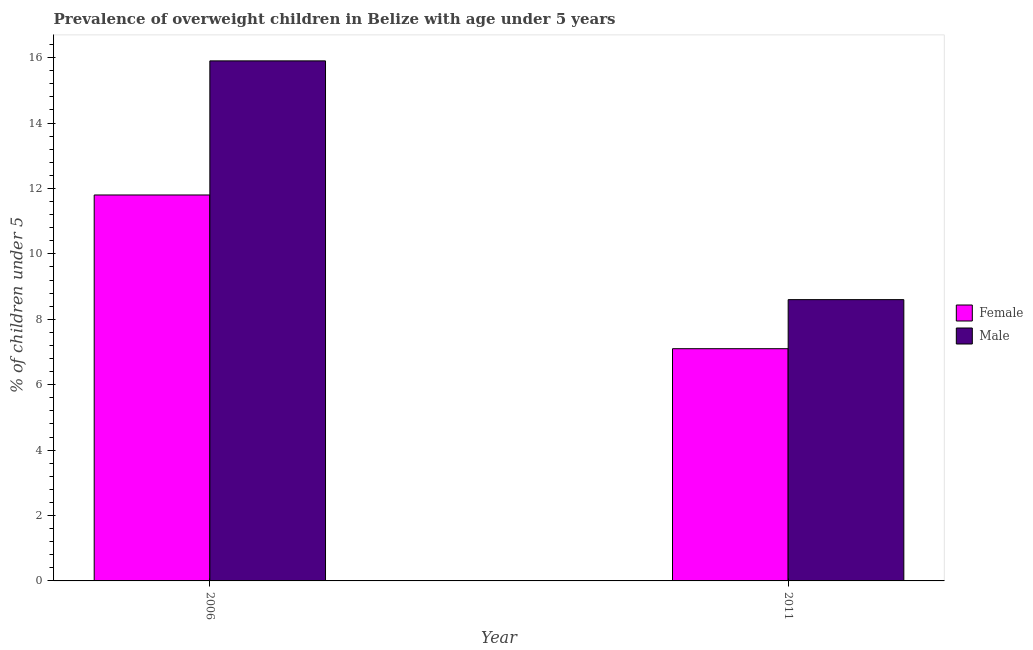How many different coloured bars are there?
Give a very brief answer. 2. How many groups of bars are there?
Provide a succinct answer. 2. Are the number of bars on each tick of the X-axis equal?
Your response must be concise. Yes. What is the label of the 1st group of bars from the left?
Keep it short and to the point. 2006. In how many cases, is the number of bars for a given year not equal to the number of legend labels?
Your answer should be very brief. 0. What is the percentage of obese male children in 2011?
Give a very brief answer. 8.6. Across all years, what is the maximum percentage of obese male children?
Provide a short and direct response. 15.9. Across all years, what is the minimum percentage of obese female children?
Your answer should be very brief. 7.1. What is the total percentage of obese female children in the graph?
Your answer should be very brief. 18.9. What is the difference between the percentage of obese male children in 2006 and that in 2011?
Your response must be concise. 7.3. What is the difference between the percentage of obese female children in 2011 and the percentage of obese male children in 2006?
Make the answer very short. -4.7. What is the average percentage of obese male children per year?
Your response must be concise. 12.25. In the year 2006, what is the difference between the percentage of obese male children and percentage of obese female children?
Make the answer very short. 0. In how many years, is the percentage of obese female children greater than 15.2 %?
Give a very brief answer. 0. What is the ratio of the percentage of obese male children in 2006 to that in 2011?
Give a very brief answer. 1.85. Is the percentage of obese male children in 2006 less than that in 2011?
Provide a succinct answer. No. What does the 1st bar from the right in 2006 represents?
Provide a short and direct response. Male. Are all the bars in the graph horizontal?
Offer a very short reply. No. How many years are there in the graph?
Offer a terse response. 2. What is the title of the graph?
Your answer should be very brief. Prevalence of overweight children in Belize with age under 5 years. What is the label or title of the Y-axis?
Your response must be concise.  % of children under 5. What is the  % of children under 5 of Female in 2006?
Offer a terse response. 11.8. What is the  % of children under 5 in Male in 2006?
Give a very brief answer. 15.9. What is the  % of children under 5 in Female in 2011?
Your answer should be compact. 7.1. What is the  % of children under 5 in Male in 2011?
Your answer should be very brief. 8.6. Across all years, what is the maximum  % of children under 5 of Female?
Make the answer very short. 11.8. Across all years, what is the maximum  % of children under 5 in Male?
Your response must be concise. 15.9. Across all years, what is the minimum  % of children under 5 of Female?
Offer a very short reply. 7.1. Across all years, what is the minimum  % of children under 5 of Male?
Give a very brief answer. 8.6. What is the difference between the  % of children under 5 in Female in 2006 and that in 2011?
Give a very brief answer. 4.7. What is the average  % of children under 5 of Female per year?
Your answer should be very brief. 9.45. What is the average  % of children under 5 of Male per year?
Offer a very short reply. 12.25. In the year 2006, what is the difference between the  % of children under 5 of Female and  % of children under 5 of Male?
Provide a succinct answer. -4.1. In the year 2011, what is the difference between the  % of children under 5 of Female and  % of children under 5 of Male?
Offer a terse response. -1.5. What is the ratio of the  % of children under 5 of Female in 2006 to that in 2011?
Offer a very short reply. 1.66. What is the ratio of the  % of children under 5 of Male in 2006 to that in 2011?
Offer a terse response. 1.85. What is the difference between the highest and the second highest  % of children under 5 of Female?
Offer a very short reply. 4.7. What is the difference between the highest and the lowest  % of children under 5 of Male?
Give a very brief answer. 7.3. 